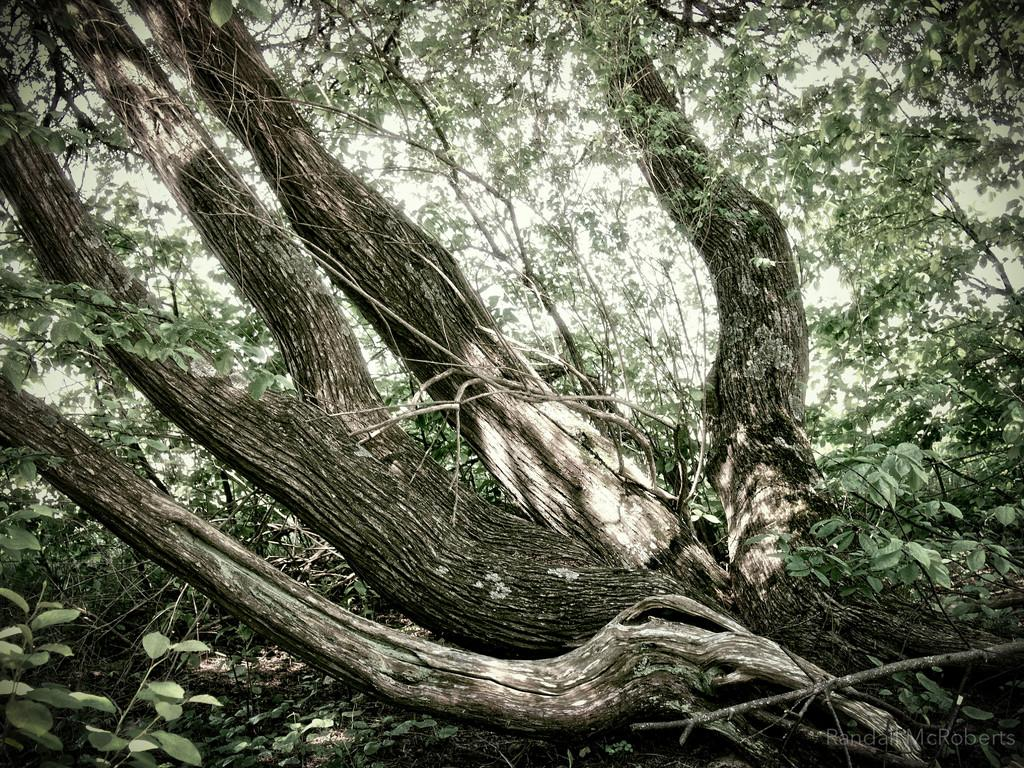What type of vegetation can be seen in the image? There are trees in the image. What part of the trees is visible in the image? There are tree trunks in the image. What is the color of the sky in the image? The sky is white in color. What type of fruit is hanging from the tree trunks in the image? There is no fruit visible in the image; only trees and tree trunks are present. What is the earth is doing in the image? There is no reference to the earth or any geological features in the image; it primarily features trees and a white sky. 